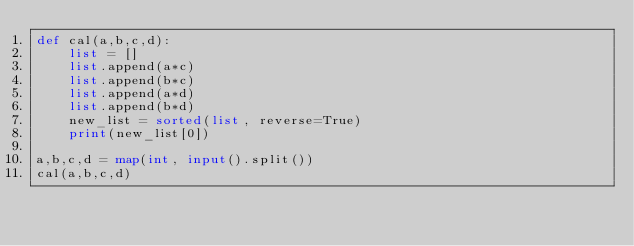Convert code to text. <code><loc_0><loc_0><loc_500><loc_500><_Python_>def cal(a,b,c,d):
    list = []
    list.append(a*c)
    list.append(b*c)
    list.append(a*d)
    list.append(b*d)
    new_list = sorted(list, reverse=True)
    print(new_list[0])

a,b,c,d = map(int, input().split())
cal(a,b,c,d)</code> 